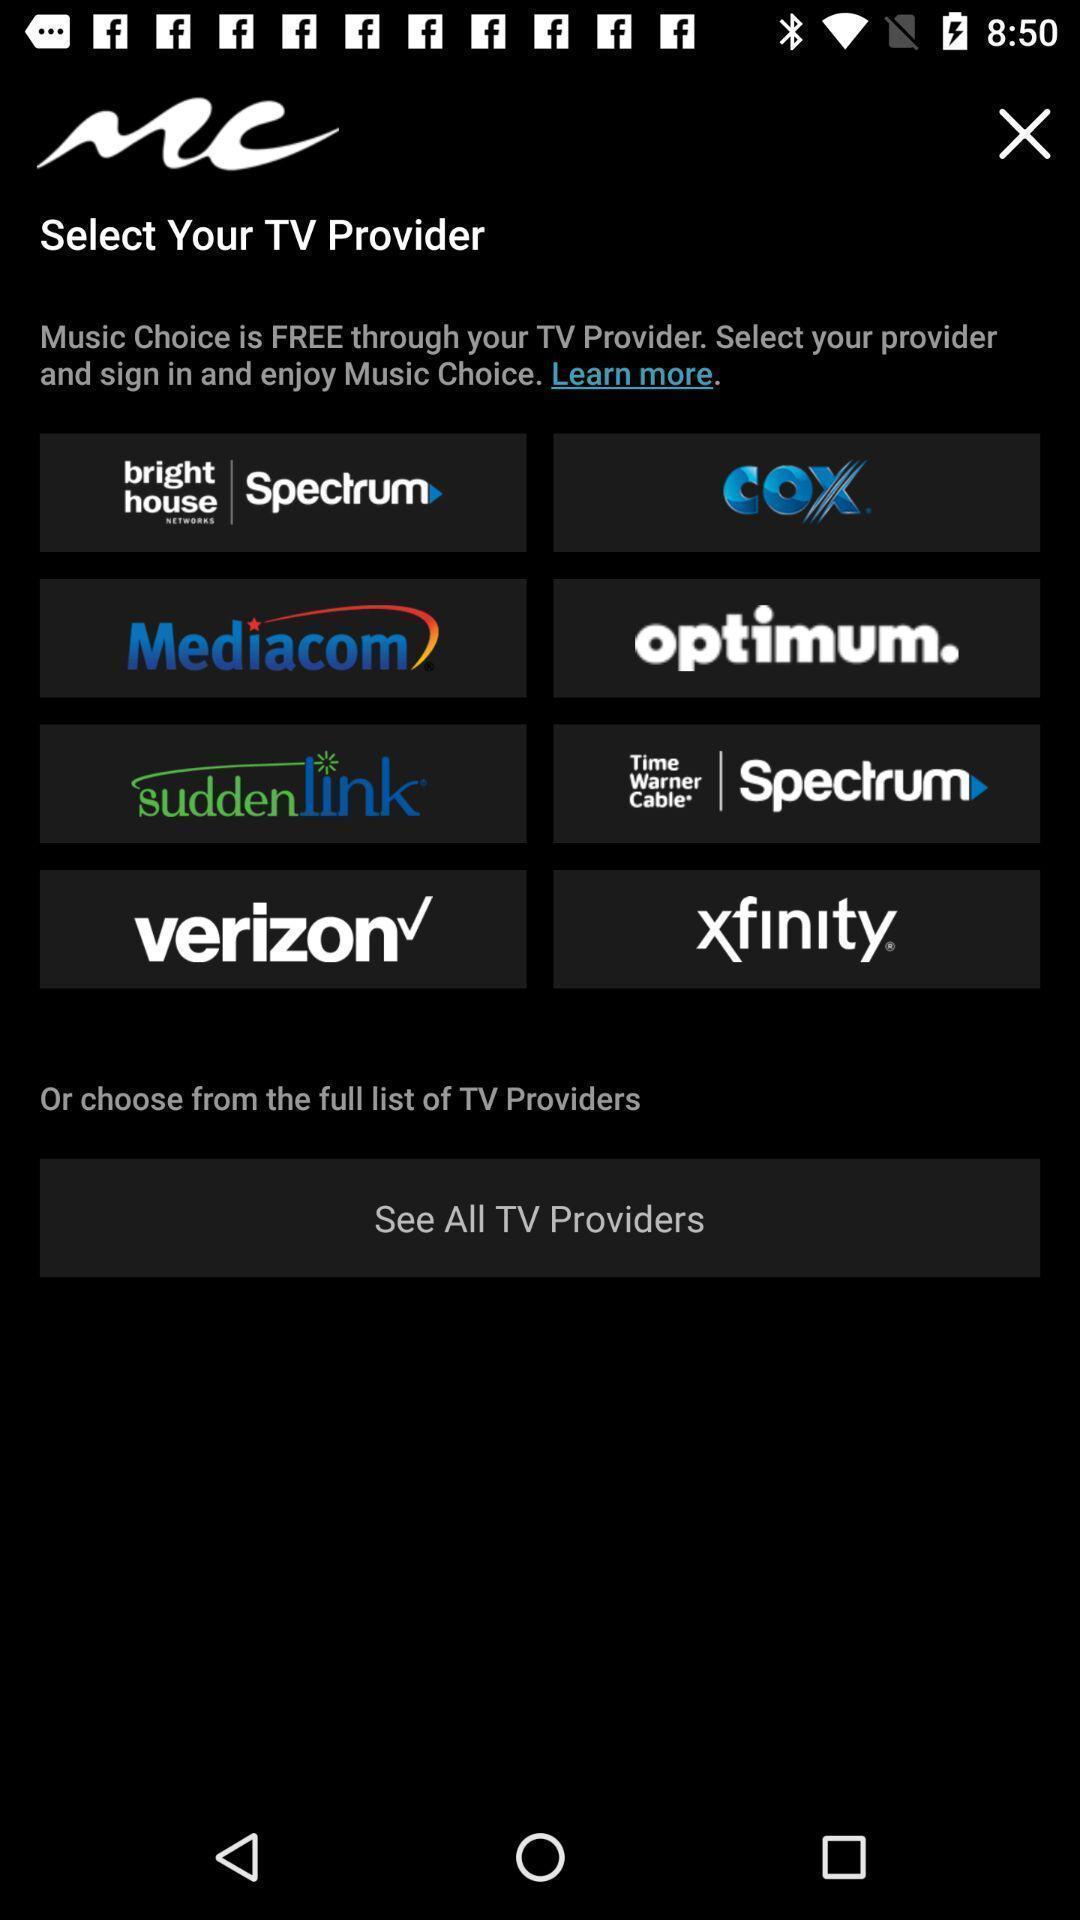Tell me about the visual elements in this screen capture. Page showing list of various providers. 